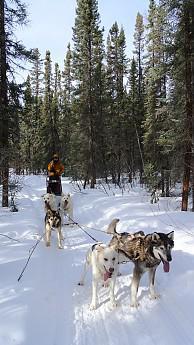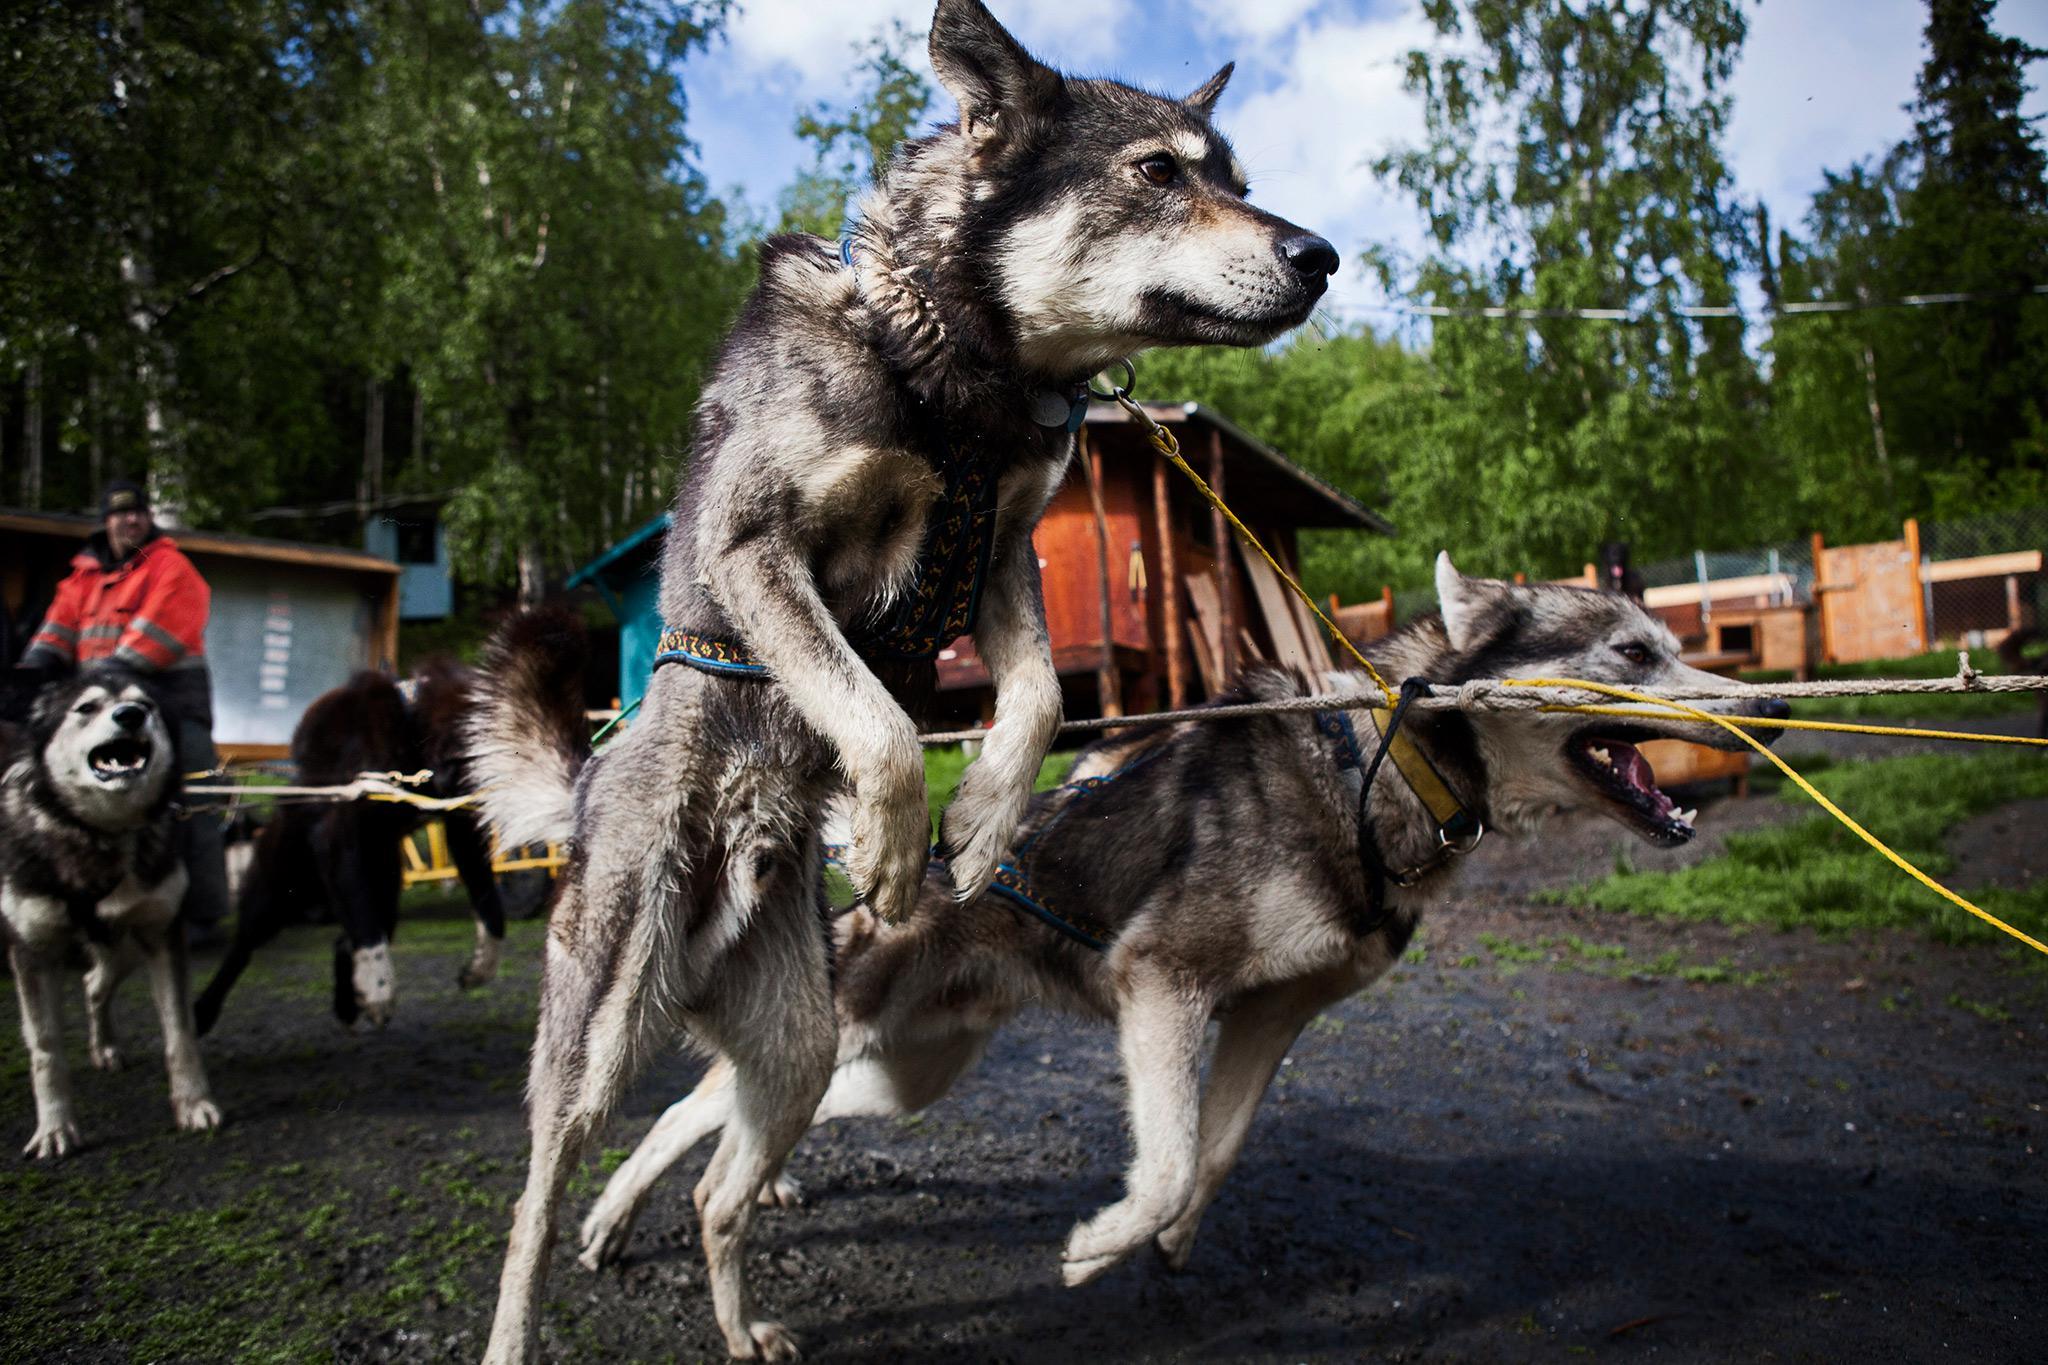The first image is the image on the left, the second image is the image on the right. Analyze the images presented: Is the assertion "There are four people with their arms and legs spread to help the sled dogs run on the path." valid? Answer yes or no. No. The first image is the image on the left, the second image is the image on the right. Given the left and right images, does the statement "Two people with outspread arms and spread legs are standing on the left as a sled dog team is coming down the trail." hold true? Answer yes or no. No. 